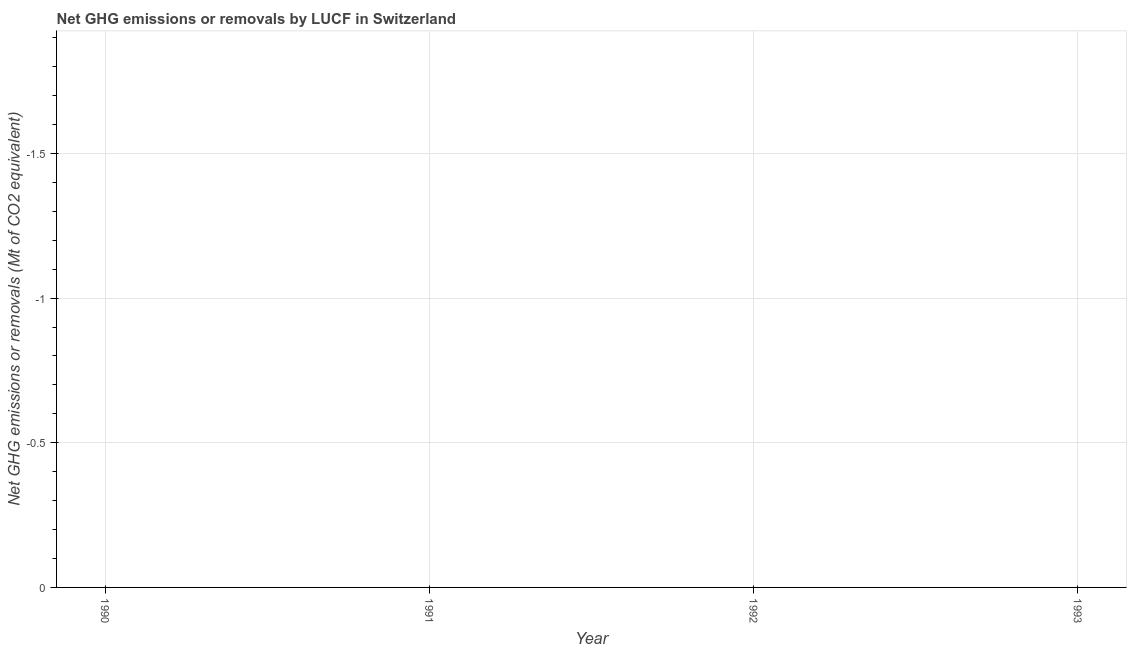What is the ghg net emissions or removals in 1990?
Your response must be concise. 0. What is the sum of the ghg net emissions or removals?
Provide a short and direct response. 0. What is the average ghg net emissions or removals per year?
Your answer should be very brief. 0. What is the median ghg net emissions or removals?
Provide a short and direct response. 0. In how many years, is the ghg net emissions or removals greater than -1.7 Mt?
Your response must be concise. 0. In how many years, is the ghg net emissions or removals greater than the average ghg net emissions or removals taken over all years?
Provide a short and direct response. 0. Does the ghg net emissions or removals monotonically increase over the years?
Give a very brief answer. No. How many dotlines are there?
Ensure brevity in your answer.  0. How many years are there in the graph?
Provide a succinct answer. 4. What is the title of the graph?
Offer a very short reply. Net GHG emissions or removals by LUCF in Switzerland. What is the label or title of the Y-axis?
Offer a very short reply. Net GHG emissions or removals (Mt of CO2 equivalent). What is the Net GHG emissions or removals (Mt of CO2 equivalent) in 1990?
Offer a terse response. 0. What is the Net GHG emissions or removals (Mt of CO2 equivalent) in 1991?
Your answer should be very brief. 0. What is the Net GHG emissions or removals (Mt of CO2 equivalent) in 1993?
Offer a terse response. 0. 